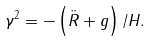<formula> <loc_0><loc_0><loc_500><loc_500>\gamma ^ { 2 } = - \left ( \ddot { R } + g \right ) / H .</formula> 